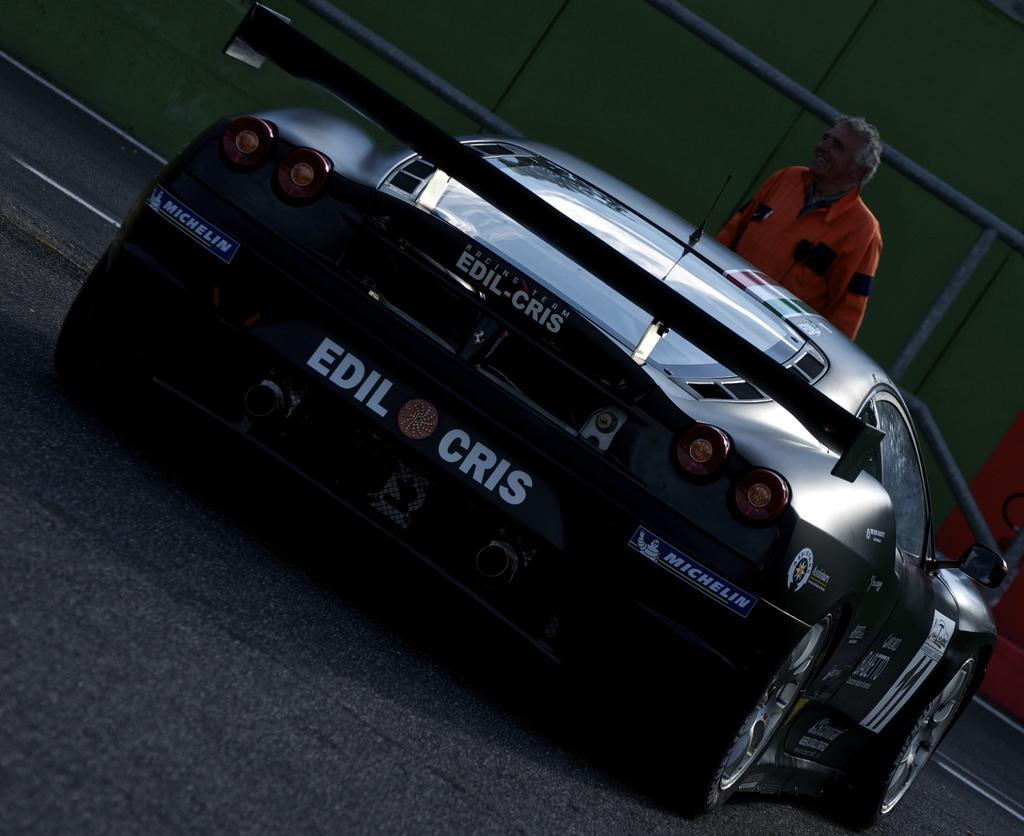What is the main subject of the picture? The main subject of the picture is a car. Where is the car located in the image? The car is on the road in the center of the picture. What can be seen in the background of the image? There are buildings and a railing in the background of the image. Can you describe the person in the background? Unfortunately, the provided facts do not give any information about the person in the background. What type of sock is the car wearing in the image? There is no car wearing a sock in the image. 